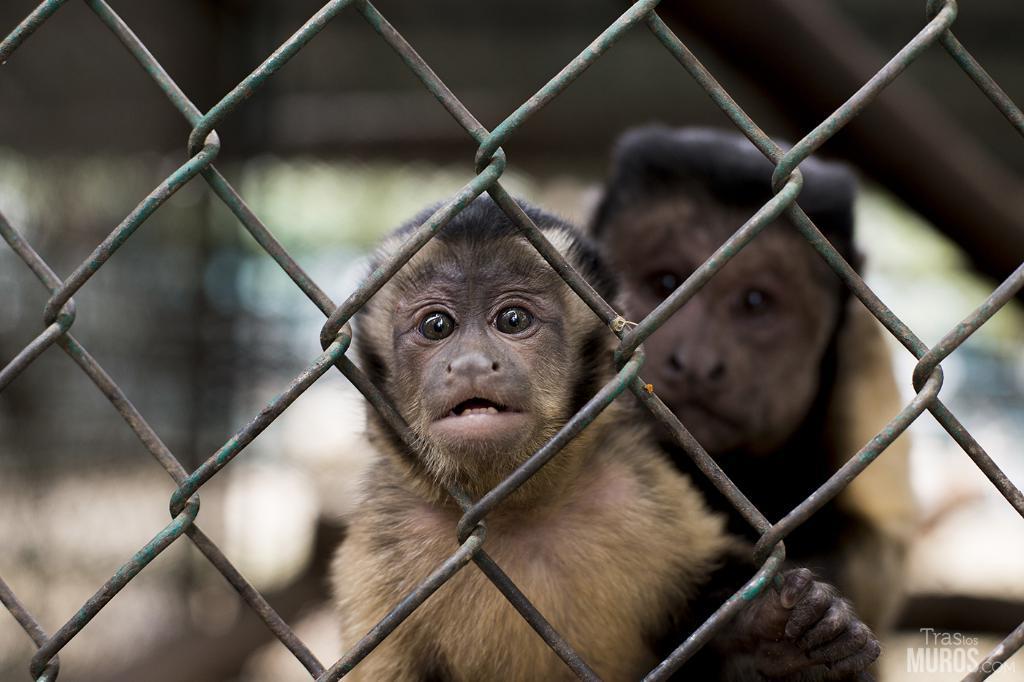Please provide a concise description of this image. In this image, I can see two monkeys. This looks like a fence. The background looks blurry. This is the watermark. 